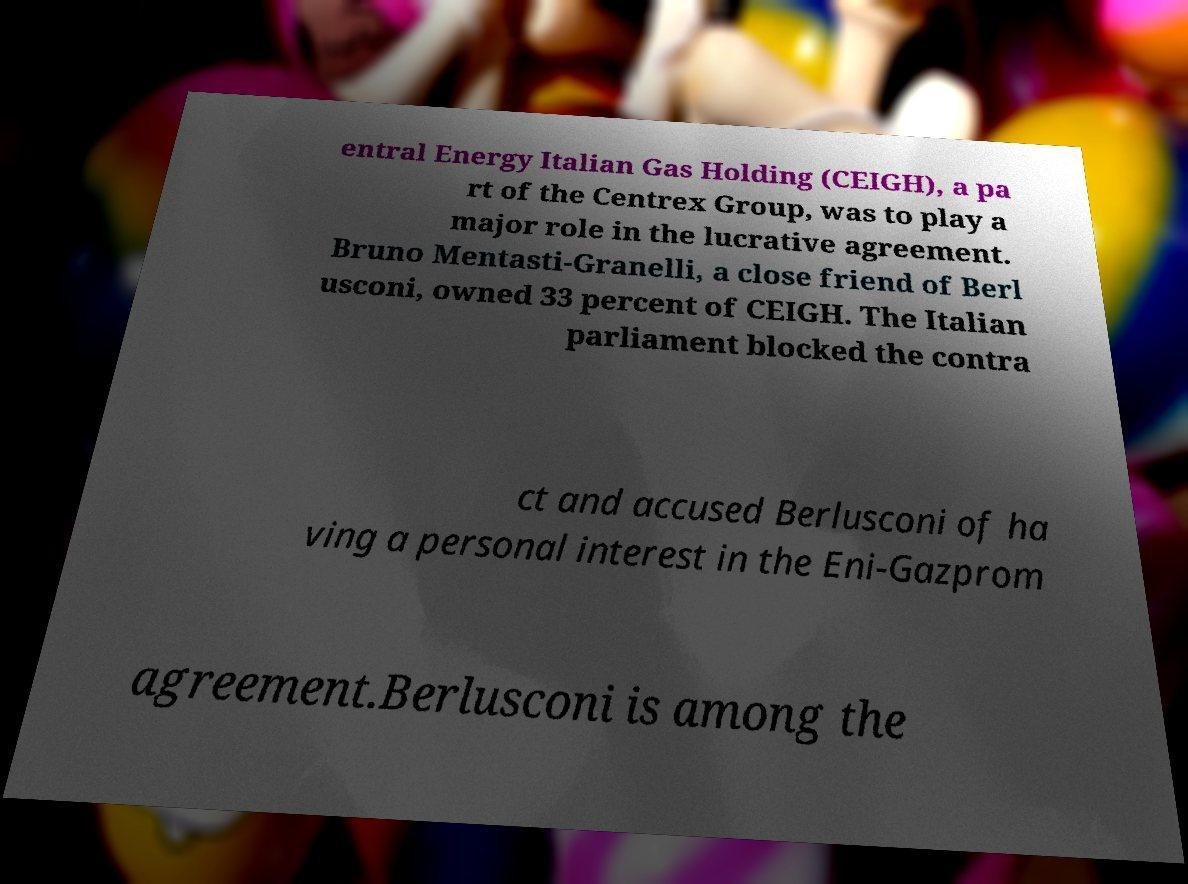Please identify and transcribe the text found in this image. entral Energy Italian Gas Holding (CEIGH), a pa rt of the Centrex Group, was to play a major role in the lucrative agreement. Bruno Mentasti-Granelli, a close friend of Berl usconi, owned 33 percent of CEIGH. The Italian parliament blocked the contra ct and accused Berlusconi of ha ving a personal interest in the Eni-Gazprom agreement.Berlusconi is among the 